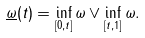Convert formula to latex. <formula><loc_0><loc_0><loc_500><loc_500>\underline { \omega } ( t ) = \inf _ { [ 0 , t ] } \omega \vee \inf _ { [ t , 1 ] } \omega .</formula> 